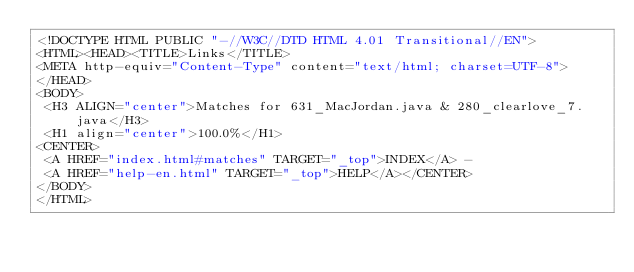Convert code to text. <code><loc_0><loc_0><loc_500><loc_500><_HTML_><!DOCTYPE HTML PUBLIC "-//W3C//DTD HTML 4.01 Transitional//EN">
<HTML><HEAD><TITLE>Links</TITLE>
<META http-equiv="Content-Type" content="text/html; charset=UTF-8">
</HEAD>
<BODY>
 <H3 ALIGN="center">Matches for 631_MacJordan.java & 280_clearlove_7.java</H3>
 <H1 align="center">100.0%</H1>
<CENTER>
 <A HREF="index.html#matches" TARGET="_top">INDEX</A> - 
 <A HREF="help-en.html" TARGET="_top">HELP</A></CENTER>
</BODY>
</HTML>
</code> 